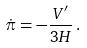<formula> <loc_0><loc_0><loc_500><loc_500>\dot { \pi } = - \frac { V ^ { \prime } } { 3 H } \, .</formula> 